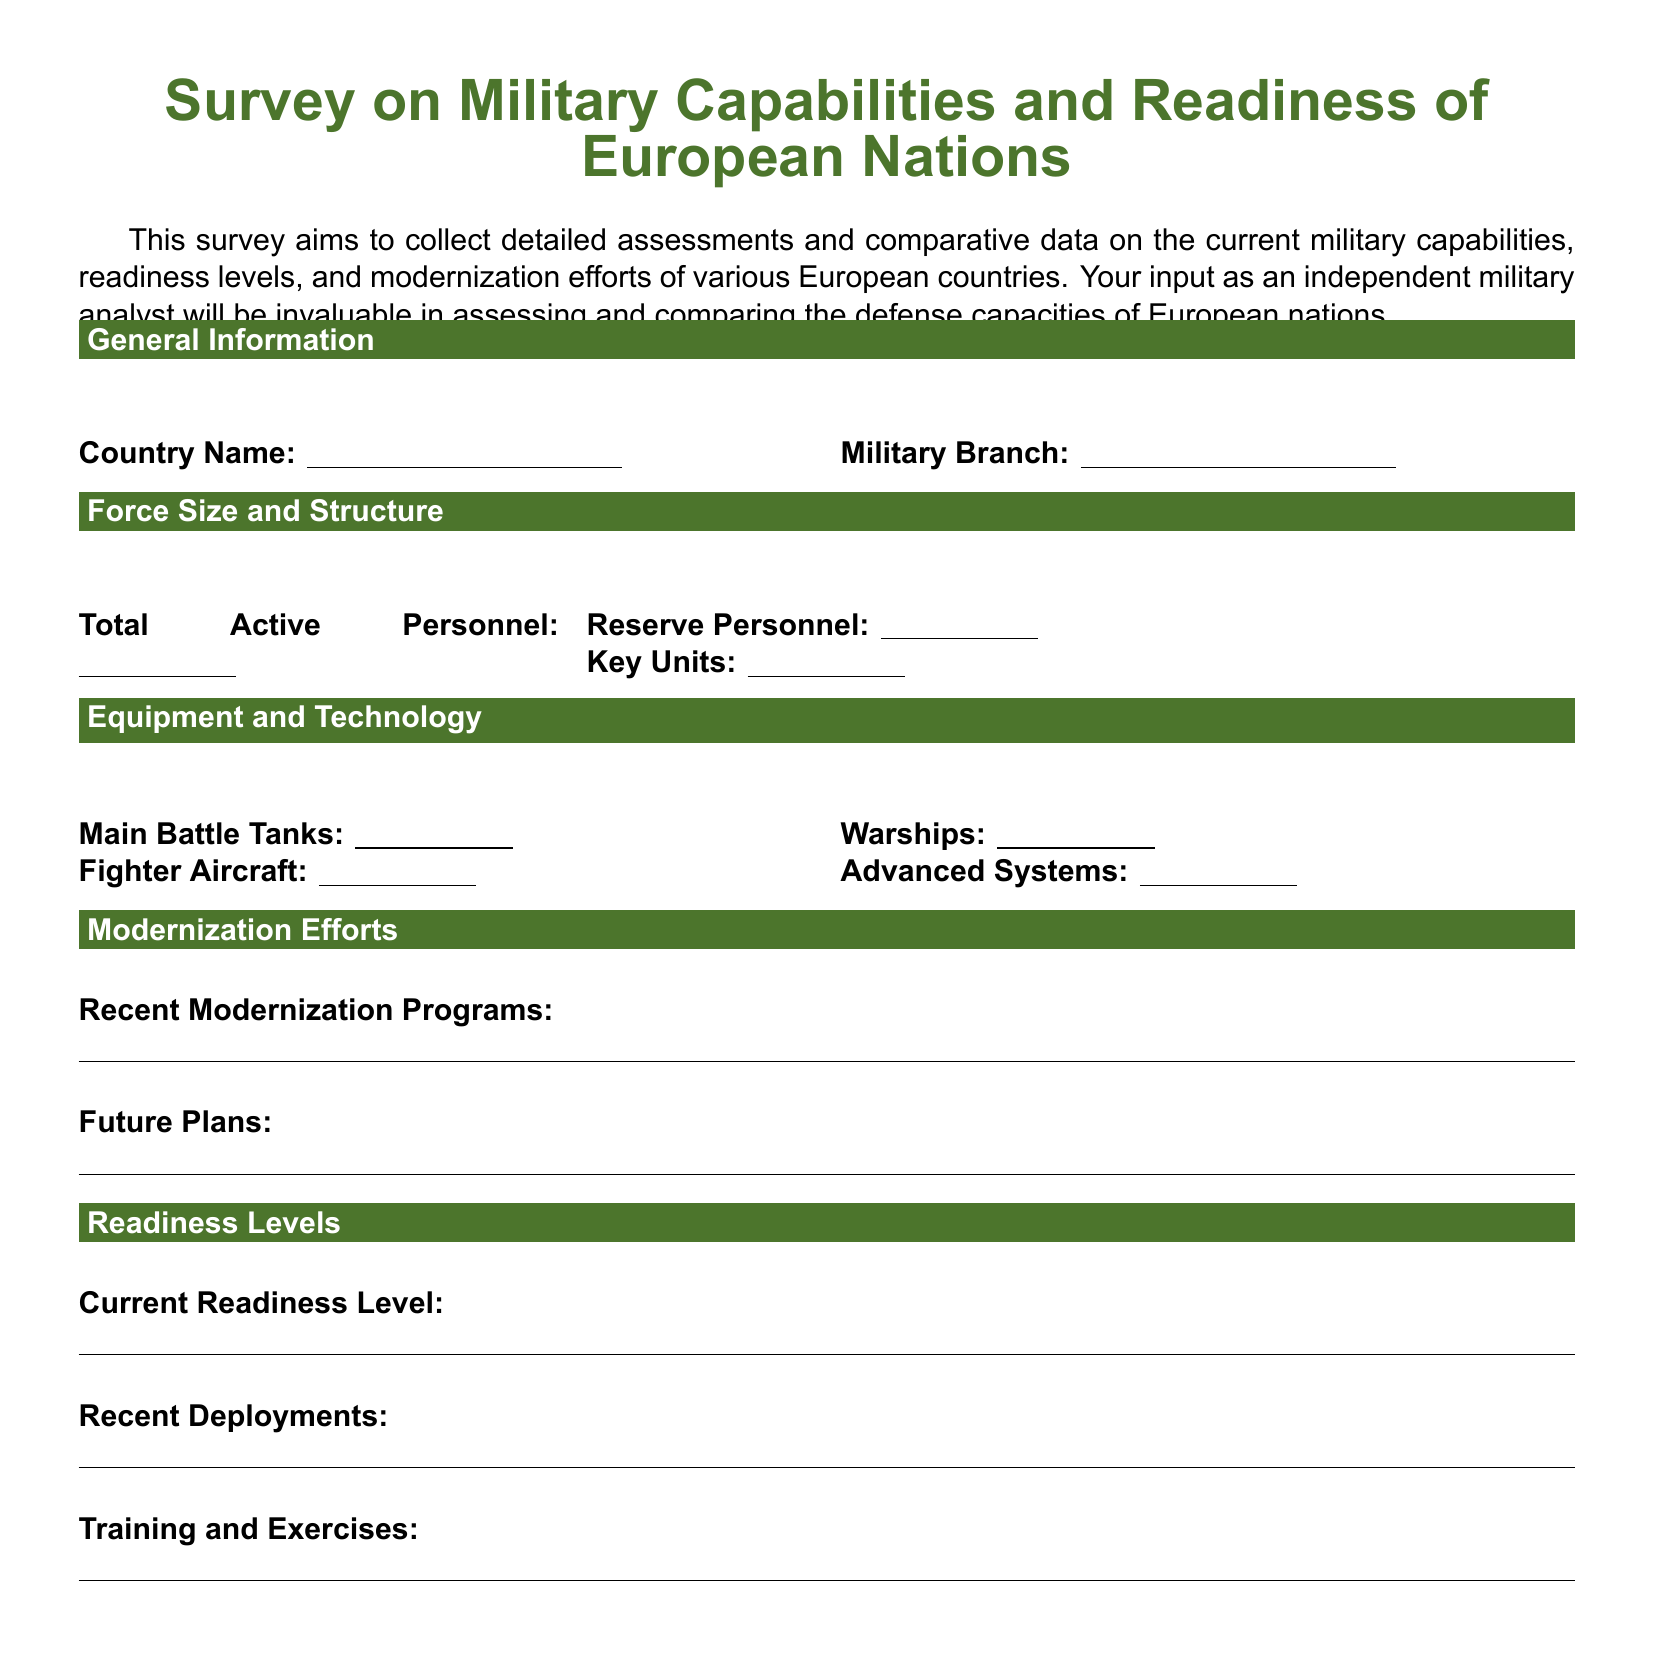What is the purpose of the survey? The purpose of the survey is to collect assessments and comparative data on military capabilities and readiness levels of European countries.
Answer: Assessments and comparative data on military capabilities and readiness levels What section covers personnel details? Personnel details are found under the section titled "Force Size and Structure."
Answer: Force Size and Structure How many columns are in the "Equipment and Technology" section? The "Equipment and Technology" section has two columns for responses.
Answer: 2 What types of military units are being assessed? The survey assesses active personnel, reserve personnel, and key military units.
Answer: Active personnel, reserve personnel, key units What does the "Modernization Efforts" section inquire about? It inquires about recent modernization programs and future plans regarding military capabilities.
Answer: Recent modernization programs and future plans What readiness level is the survey asking for? The survey asks for information on the current readiness level of the military.
Answer: Current readiness level What type of aircraft is specifically mentioned in the equipment section? Fighter aircraft are specifically mentioned in the equipment section.
Answer: Fighter aircraft What is the expected format for answering questions in the survey? The expected format for answers is short-answer responses indicated by underlines.
Answer: Short-answer responses indicated by underlines 